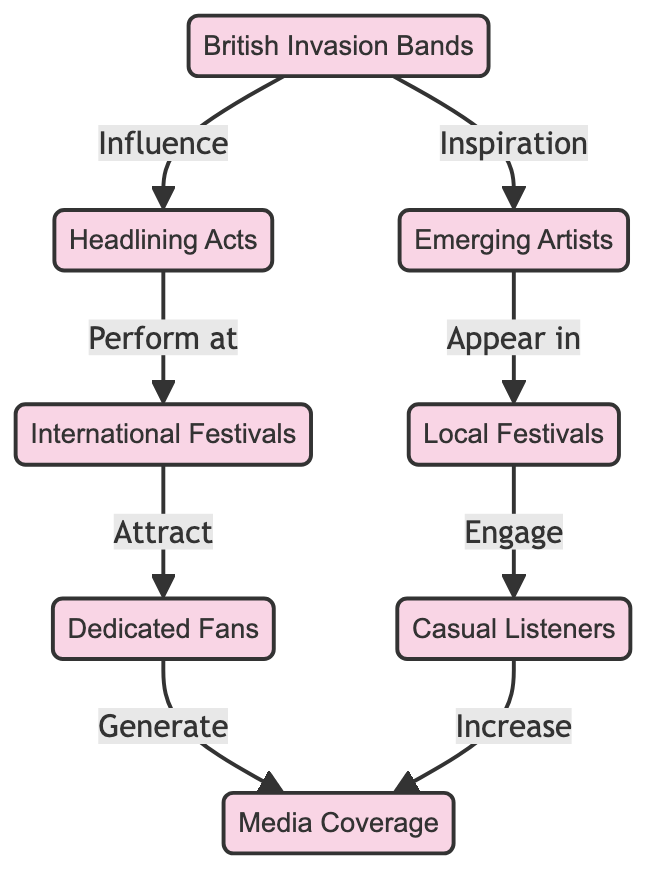What is the starting point of the food chain? The food chain begins with the node "British Invasion Bands," signifying their role as the initial influence in the flow of the diagram.
Answer: British Invasion Bands How many nodes are present in the diagram? The diagram contains a total of eight distinct nodes representing various elements of the food chain.
Answer: 8 Which group generates media coverage? Both "Dedicated Fans" and "Casual Listeners" are responsible for generating media coverage, indicating that both groups contribute to this aspect.
Answer: Dedicated Fans, Casual Listeners What is the relationship between British Invasion Bands and Emerging Artists? British Invasion Bands provide inspiration to Emerging Artists, demonstrating a creative link between these two categories in the music industry.
Answer: Inspiration Which type of festivals do Headlining Acts perform at? Headlining Acts perform at International Festivals, indicating a level of prestige and recognition for these acts within the festival scene.
Answer: International Festivals Which audience engages with Local Festivals? Casual Listeners are the audience that engages with Local Festivals, suggesting they are attracted to more accessible and regional events.
Answer: Casual Listeners What do International Festivals attract? International Festivals attract Dedicated Fans, highlighting their significance in the music culture as they draw in loyal supporters.
Answer: Dedicated Fans What role do Casual Listeners play in the media coverage? Casual Listeners increase media coverage, indicating their potential to amplify attention and reach in broader audiences beyond dedicated followers.
Answer: Increase 